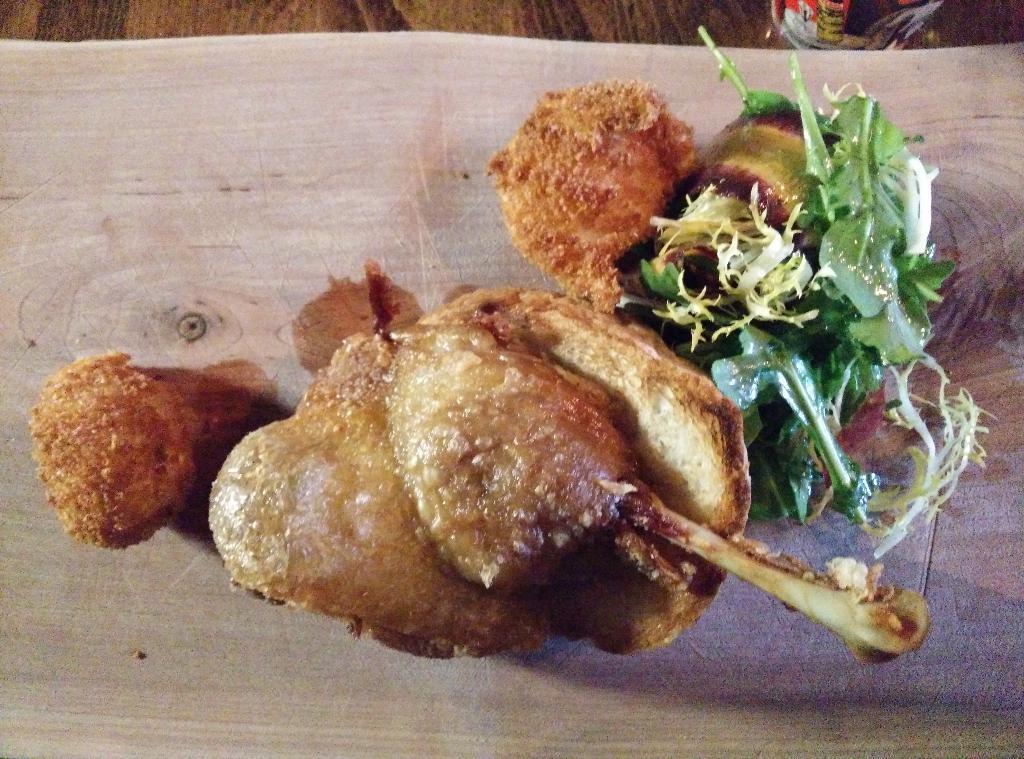Please provide a concise description of this image. In this image we can see meat placed on the table. 